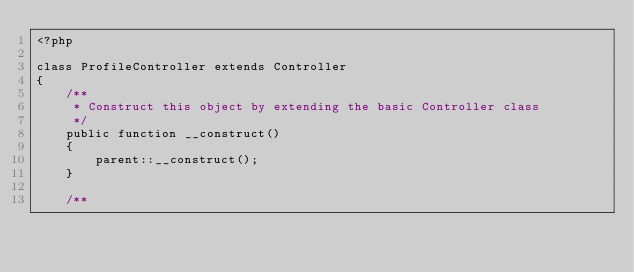Convert code to text. <code><loc_0><loc_0><loc_500><loc_500><_PHP_><?php

class ProfileController extends Controller
{
    /**
     * Construct this object by extending the basic Controller class
     */
    public function __construct()
    {
        parent::__construct();
    }

    /**</code> 